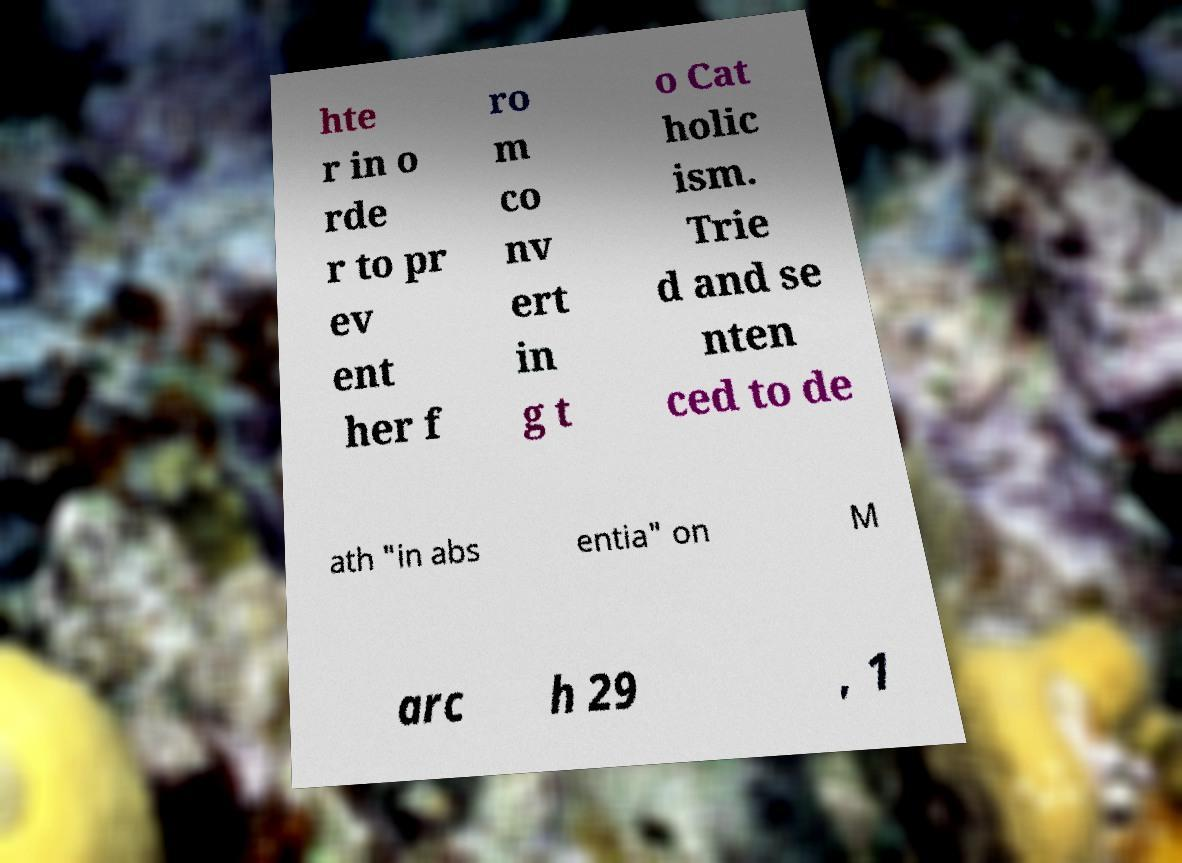I need the written content from this picture converted into text. Can you do that? hte r in o rde r to pr ev ent her f ro m co nv ert in g t o Cat holic ism. Trie d and se nten ced to de ath "in abs entia" on M arc h 29 , 1 